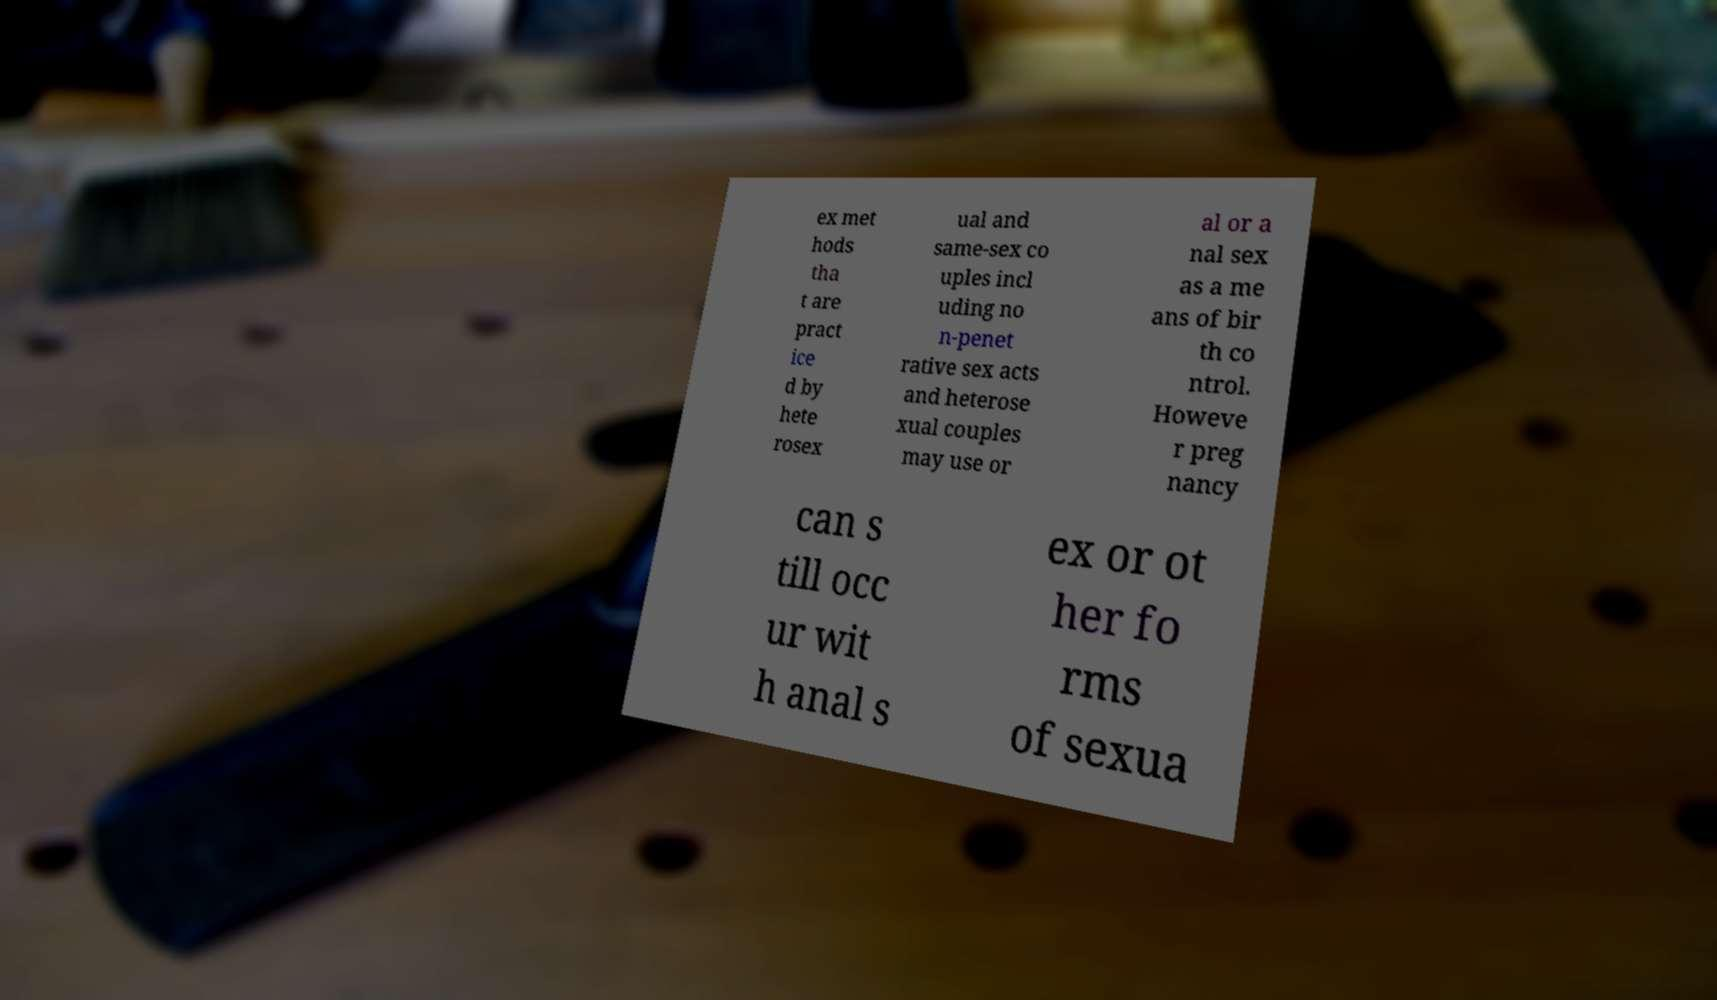Can you accurately transcribe the text from the provided image for me? ex met hods tha t are pract ice d by hete rosex ual and same-sex co uples incl uding no n-penet rative sex acts and heterose xual couples may use or al or a nal sex as a me ans of bir th co ntrol. Howeve r preg nancy can s till occ ur wit h anal s ex or ot her fo rms of sexua 